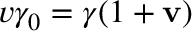Convert formula to latex. <formula><loc_0><loc_0><loc_500><loc_500>v \gamma _ { 0 } = \gamma ( 1 + v )</formula> 